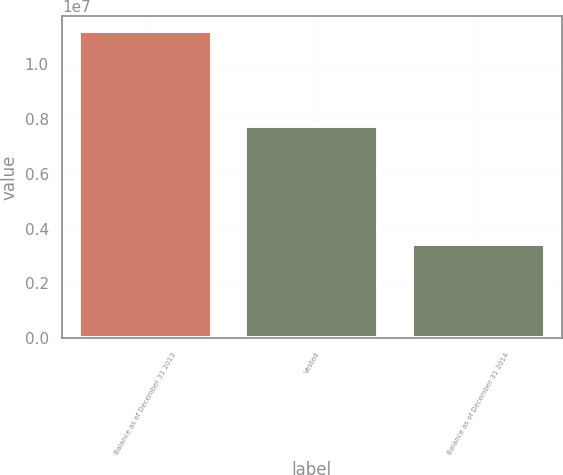Convert chart. <chart><loc_0><loc_0><loc_500><loc_500><bar_chart><fcel>Balance as of December 31 2013<fcel>Vested<fcel>Balance as of December 31 2014<nl><fcel>1.11958e+07<fcel>7.74997e+06<fcel>3.44581e+06<nl></chart> 